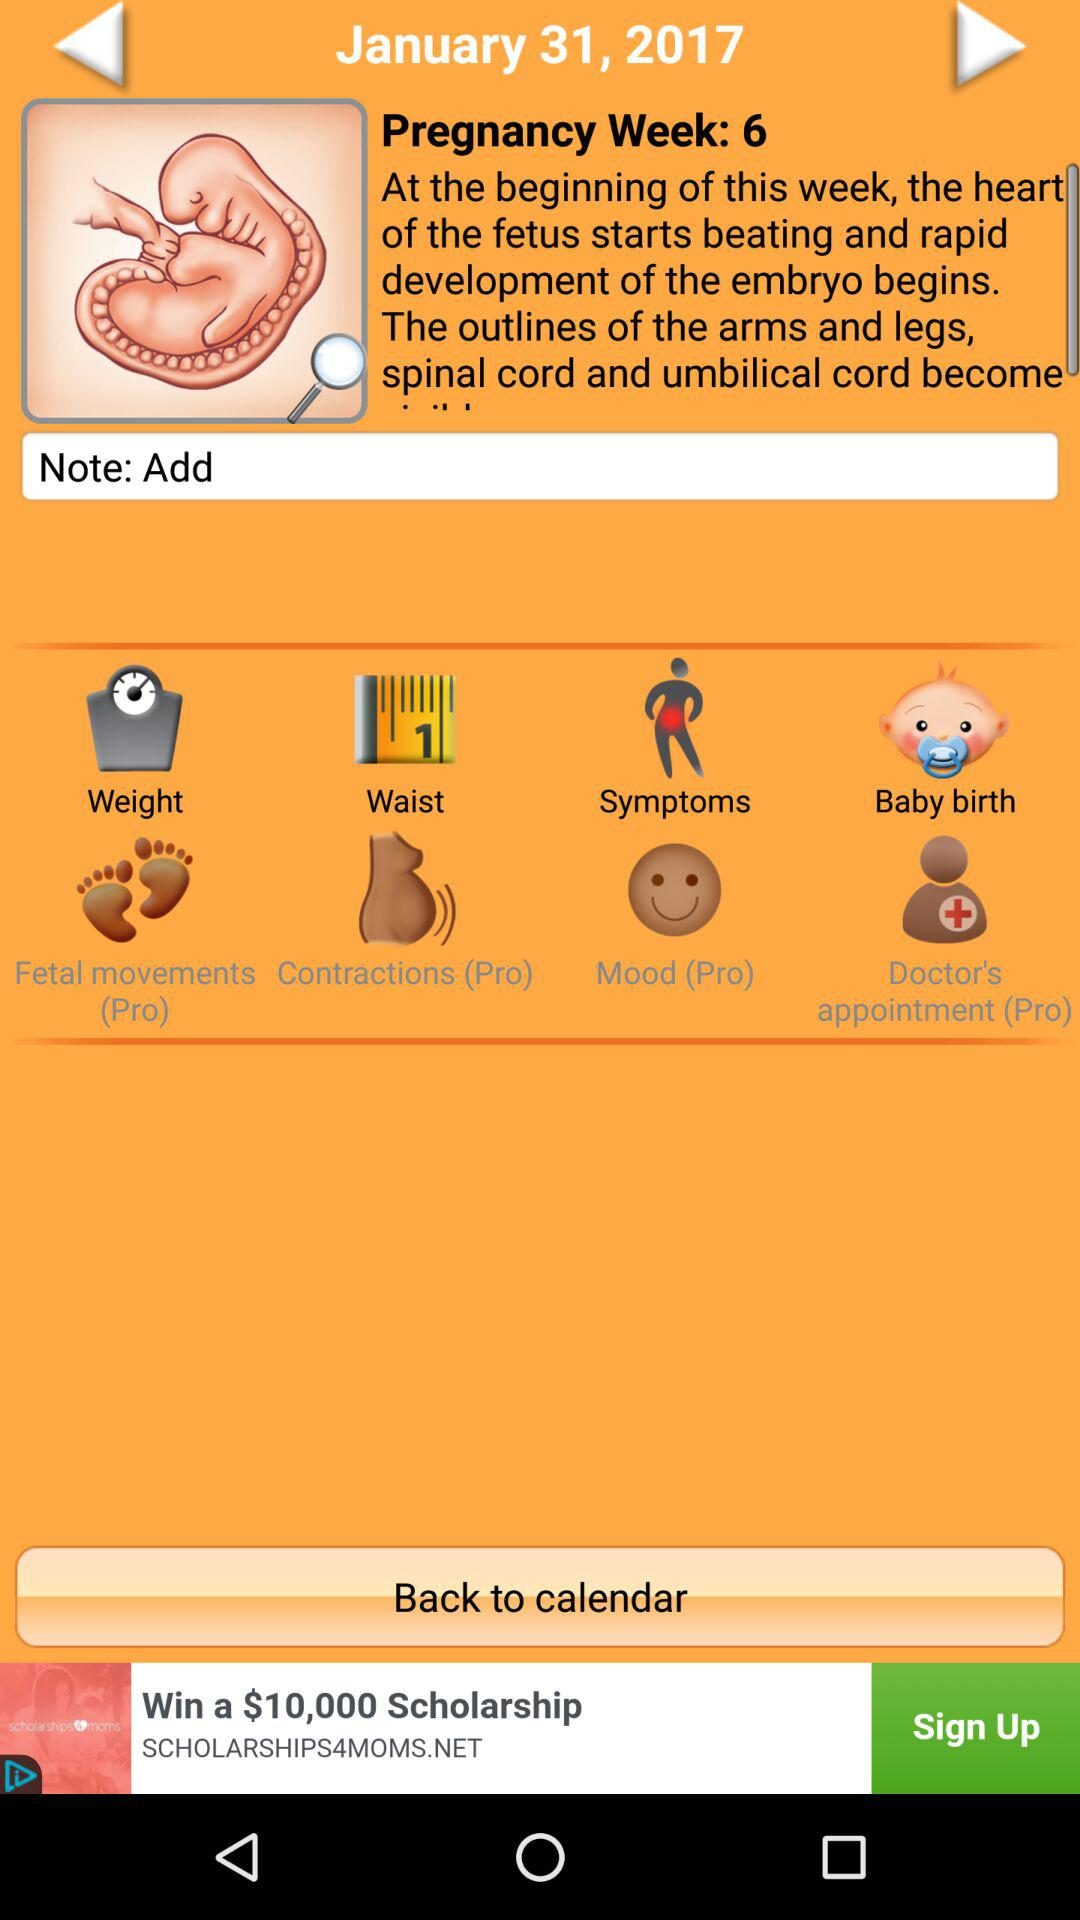What is the date? The date is January 31, 2017. 